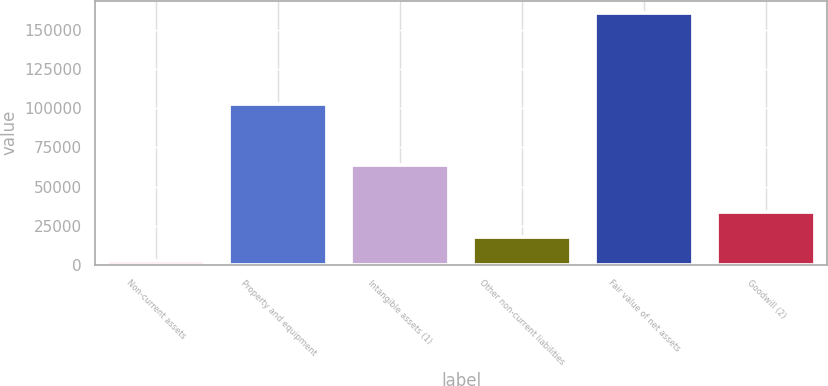Convert chart to OTSL. <chart><loc_0><loc_0><loc_500><loc_500><bar_chart><fcel>Non-current assets<fcel>Property and equipment<fcel>Intangible assets (1)<fcel>Other non-current liabilities<fcel>Fair value of net assets<fcel>Goodwill (2)<nl><fcel>2258<fcel>102366<fcel>63500<fcel>18091.8<fcel>160596<fcel>33925.6<nl></chart> 